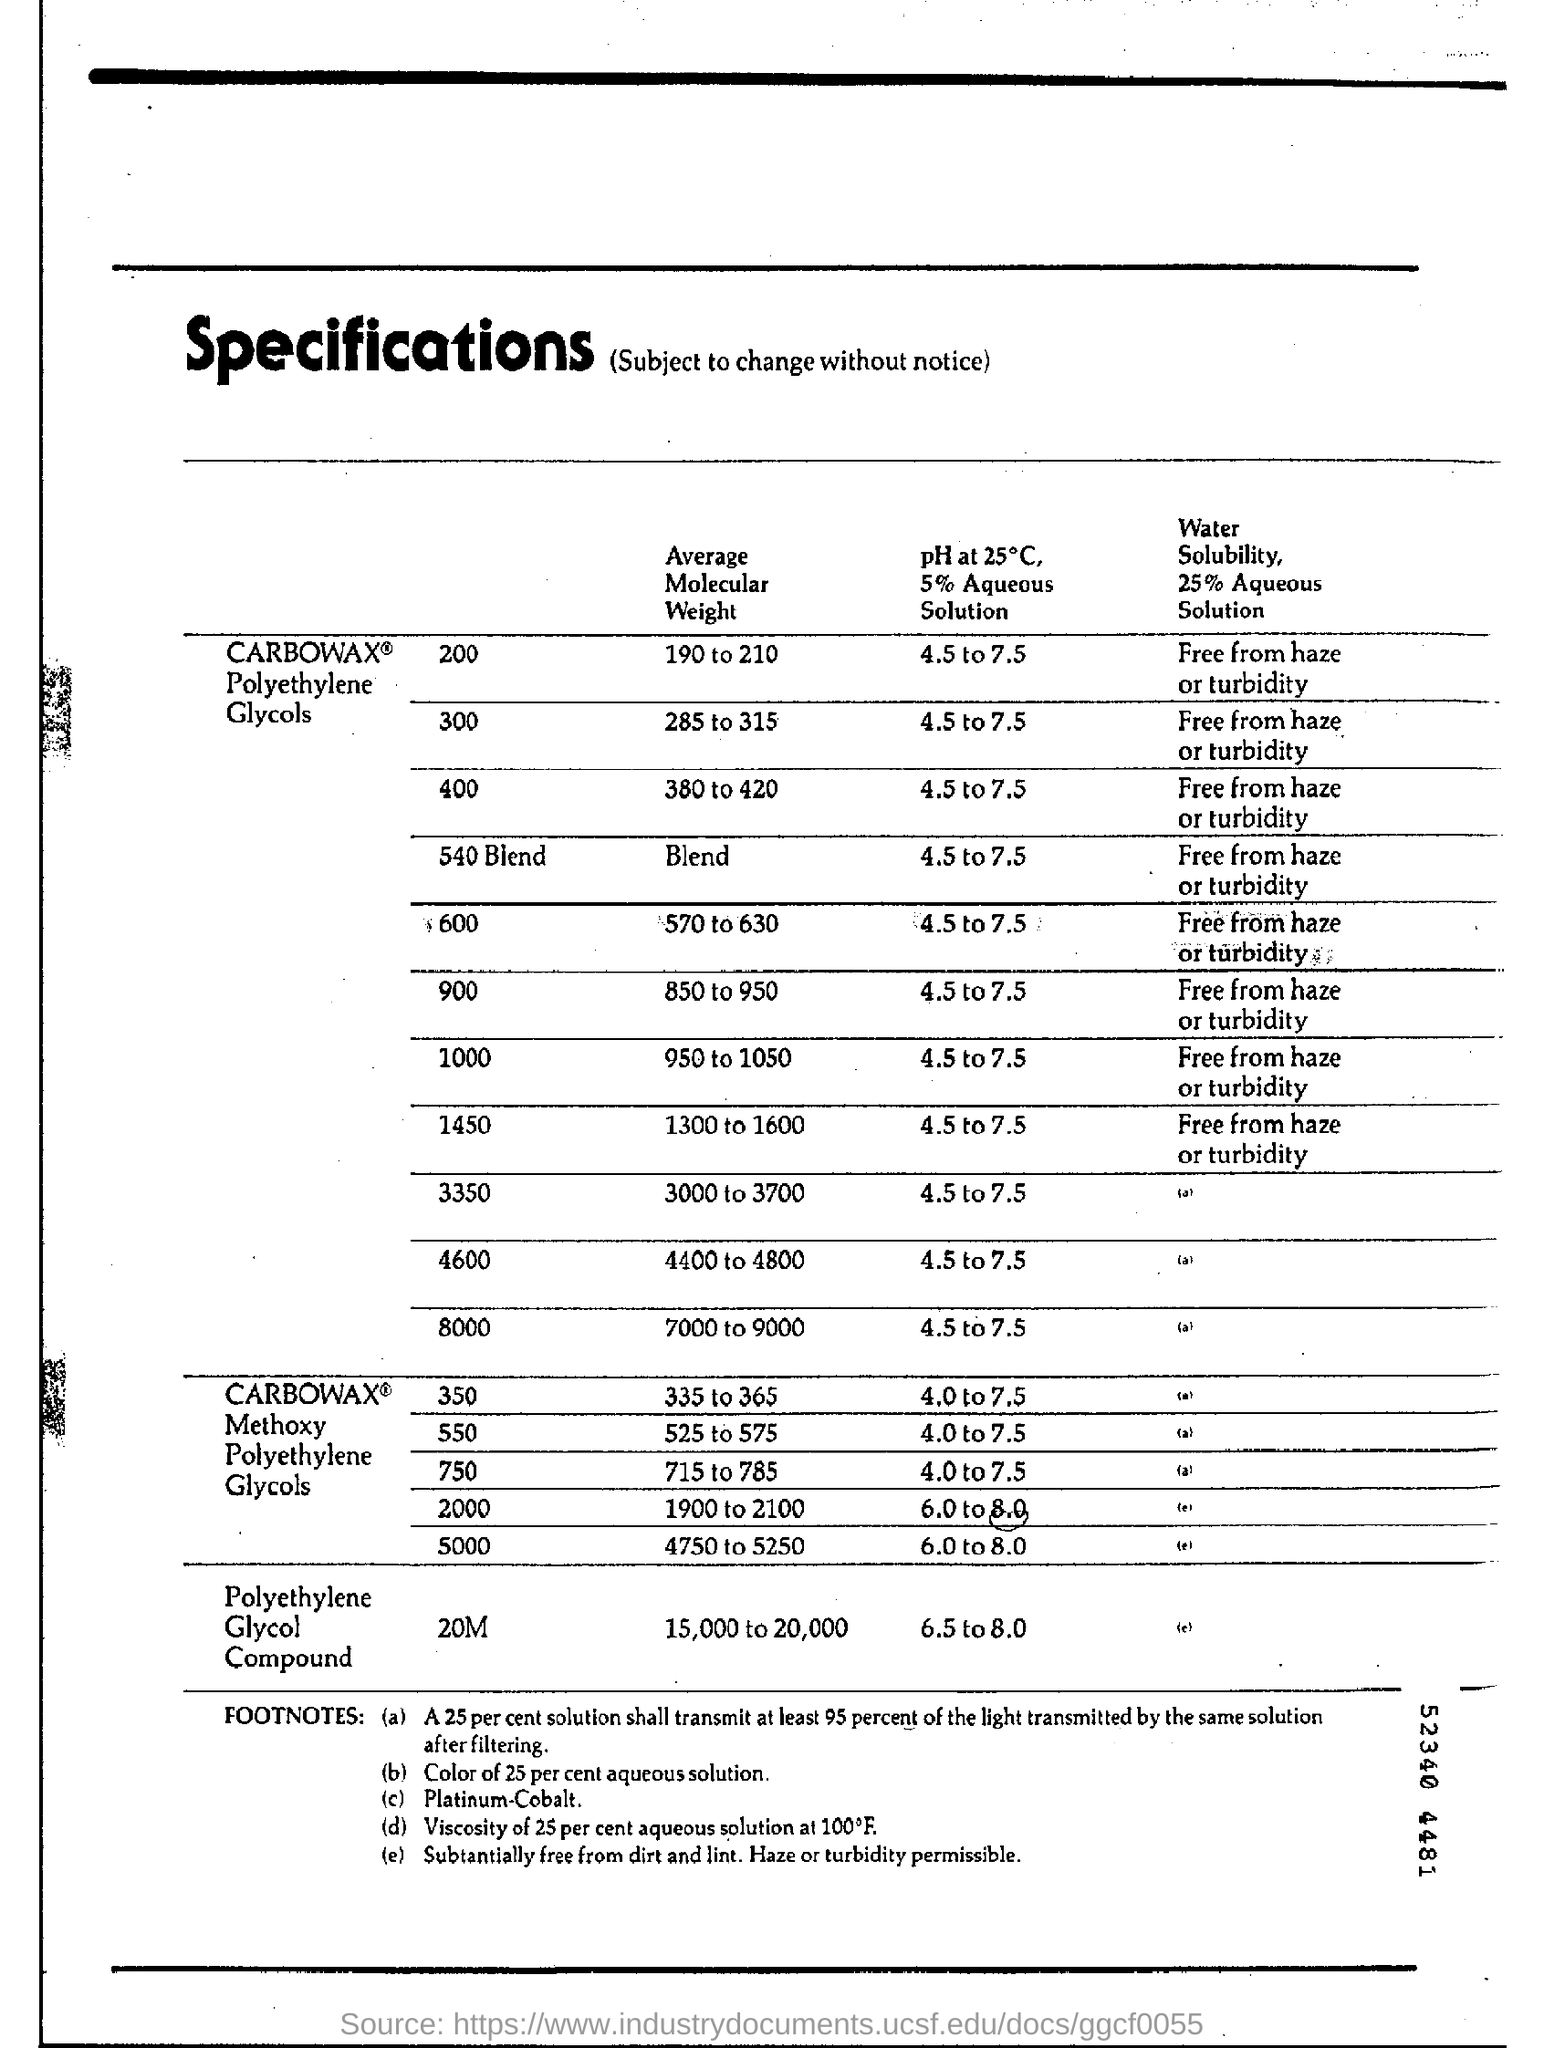Average molecular weight of polyethylene glycol compound?
Your answer should be compact. 15,000 to 20000. 